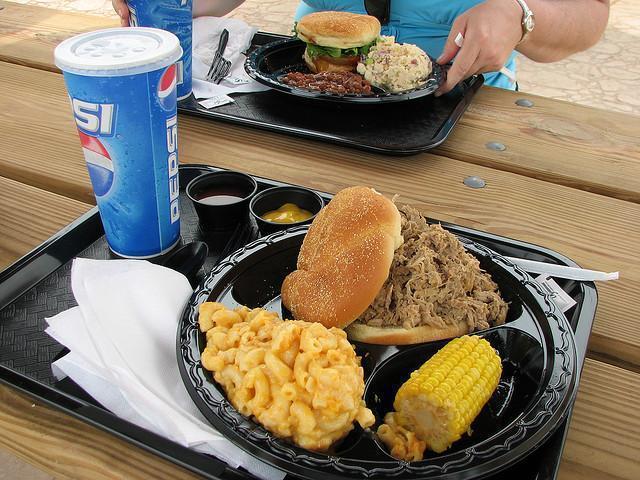Which item on the plate is highest in carbs if the person ate all of it?
Indicate the correct response and explain using: 'Answer: answer
Rationale: rationale.'
Options: Pork, corn, hamburger bun, macaroni. Answer: macaroni.
Rationale: It is the largest quantity of food on the plate 